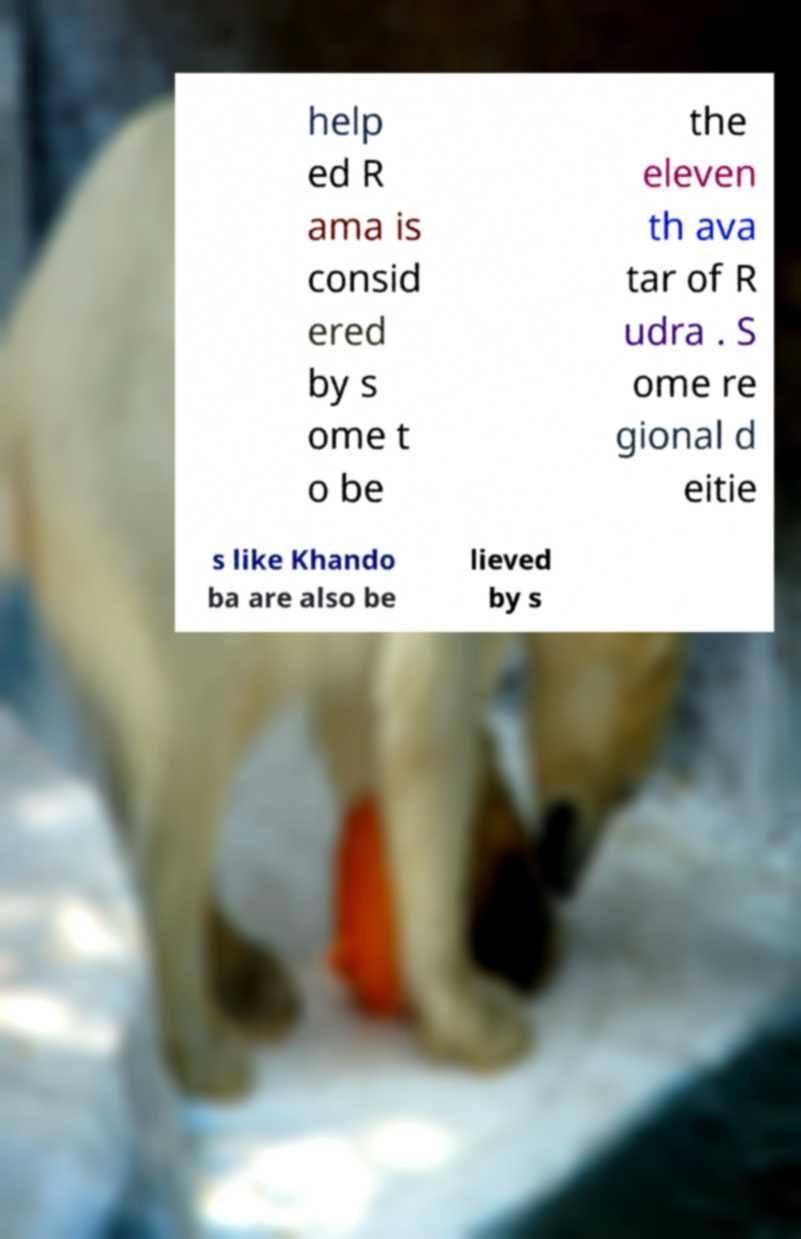Could you assist in decoding the text presented in this image and type it out clearly? help ed R ama is consid ered by s ome t o be the eleven th ava tar of R udra . S ome re gional d eitie s like Khando ba are also be lieved by s 